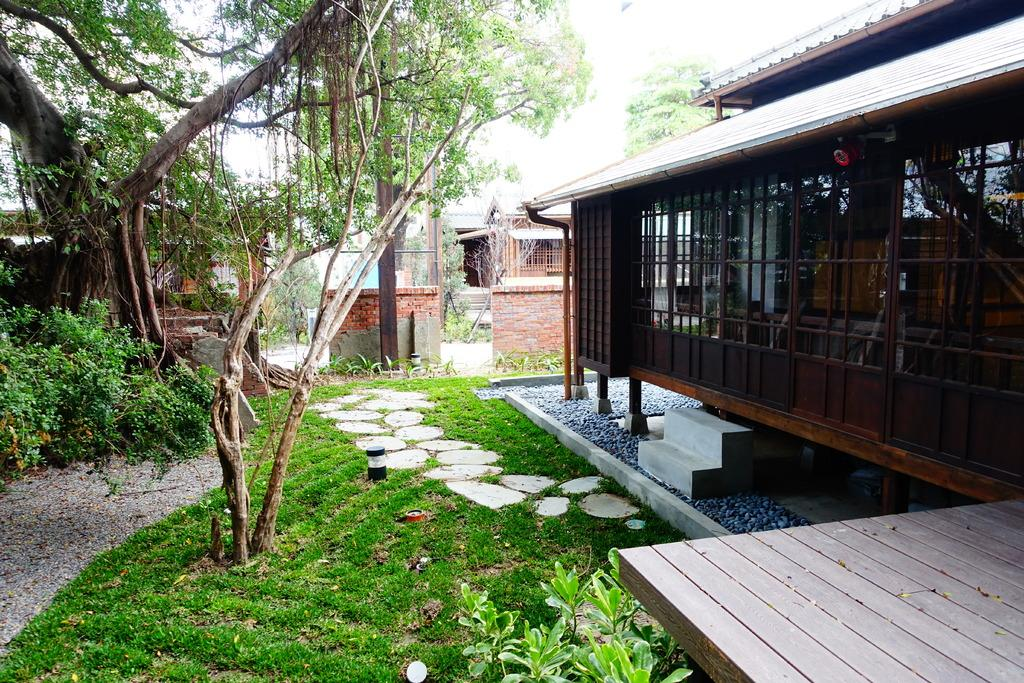What type of vegetation covers the land in the image? The land is covered with grass in the image. What other types of vegetation can be seen in the image? There are plants and trees in the image. What type of windows are featured on the houses in the image? The houses in the image have glass windows. What type of pipe is visible in the image? There is no pipe present in the image. Who is the partner of the person standing next to the tree in the image? There is no person standing next to the tree in the image. 